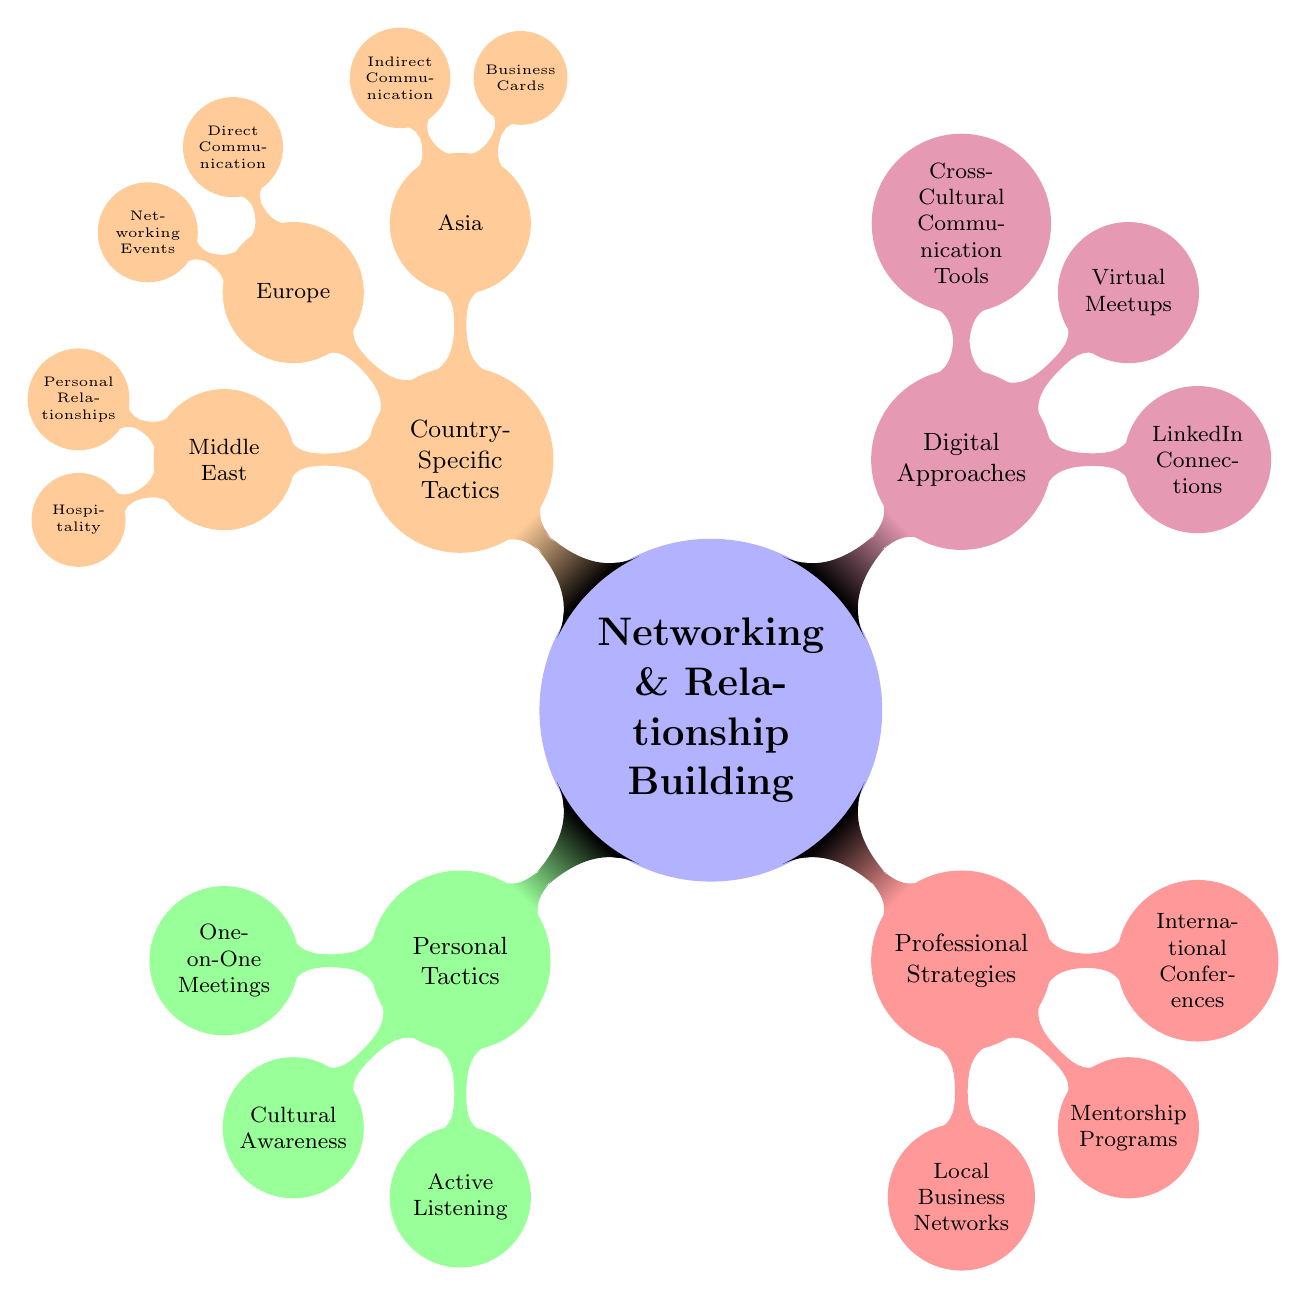What are the three main categories of networking tactics? The diagram shows four main categories: Personal Tactics, Professional Strategies, Digital Approaches, and Country-Specific Tactics. These categories are the primary divisions for organizing the information about networking.
Answer: Personal Tactics, Professional Strategies, Digital Approaches, Country-Specific Tactics How many tactics are listed under Digital Approaches? In the diagram, there are three tactics listed under Digital Approaches: LinkedIn Connections, Virtual Meetups, and Cross-Cultural Communication Tools. Therefore, the total count is three.
Answer: 3 What is a tactic mentioned under Country-Specific Tactics for Asia? The diagram indicates that one of the tactics for Asia is "Indirect Communication," which aligns with the cultural norms outlined for that region.
Answer: Indirect Communication Which type of communication style is emphasized in Europe? The diagram states that Europe emphasizes "Direct Communication," indicating a preference for straightforward exchanges in networking contexts.
Answer: Direct Communication How can mentorship programs be categorized within the networking tactics? Based on the diagram, mentorship programs fall under Professional Strategies, which focuses on building professional connections and relationships.
Answer: Professional Strategies How many tactics are included under Country-Specific Tactics overall? Analyzing the diagram reveals that there are six tactics overall in the Country-Specific Tactics section, with two from Asia, two from Europe, and two from the Middle East.
Answer: 6 What is one way to build trust according to Personal Tactics? The diagram highlights that "One-on-One Meetings" help build trust through personal interactions, thereby fostering stronger relationships.
Answer: One-on-One Meetings Which digital approach is responsible for building a professional online network? The diagram points to "LinkedIn Connections" as the specific digital approach aimed at maintaining an online professional network.
Answer: LinkedIn Connections What is a common element across all country-specific tactics? The common element across all country-specific tactics is the emphasis on building personal relationships, as seen in Asia, Europe, and the Middle East.
Answer: Building personal relationships 